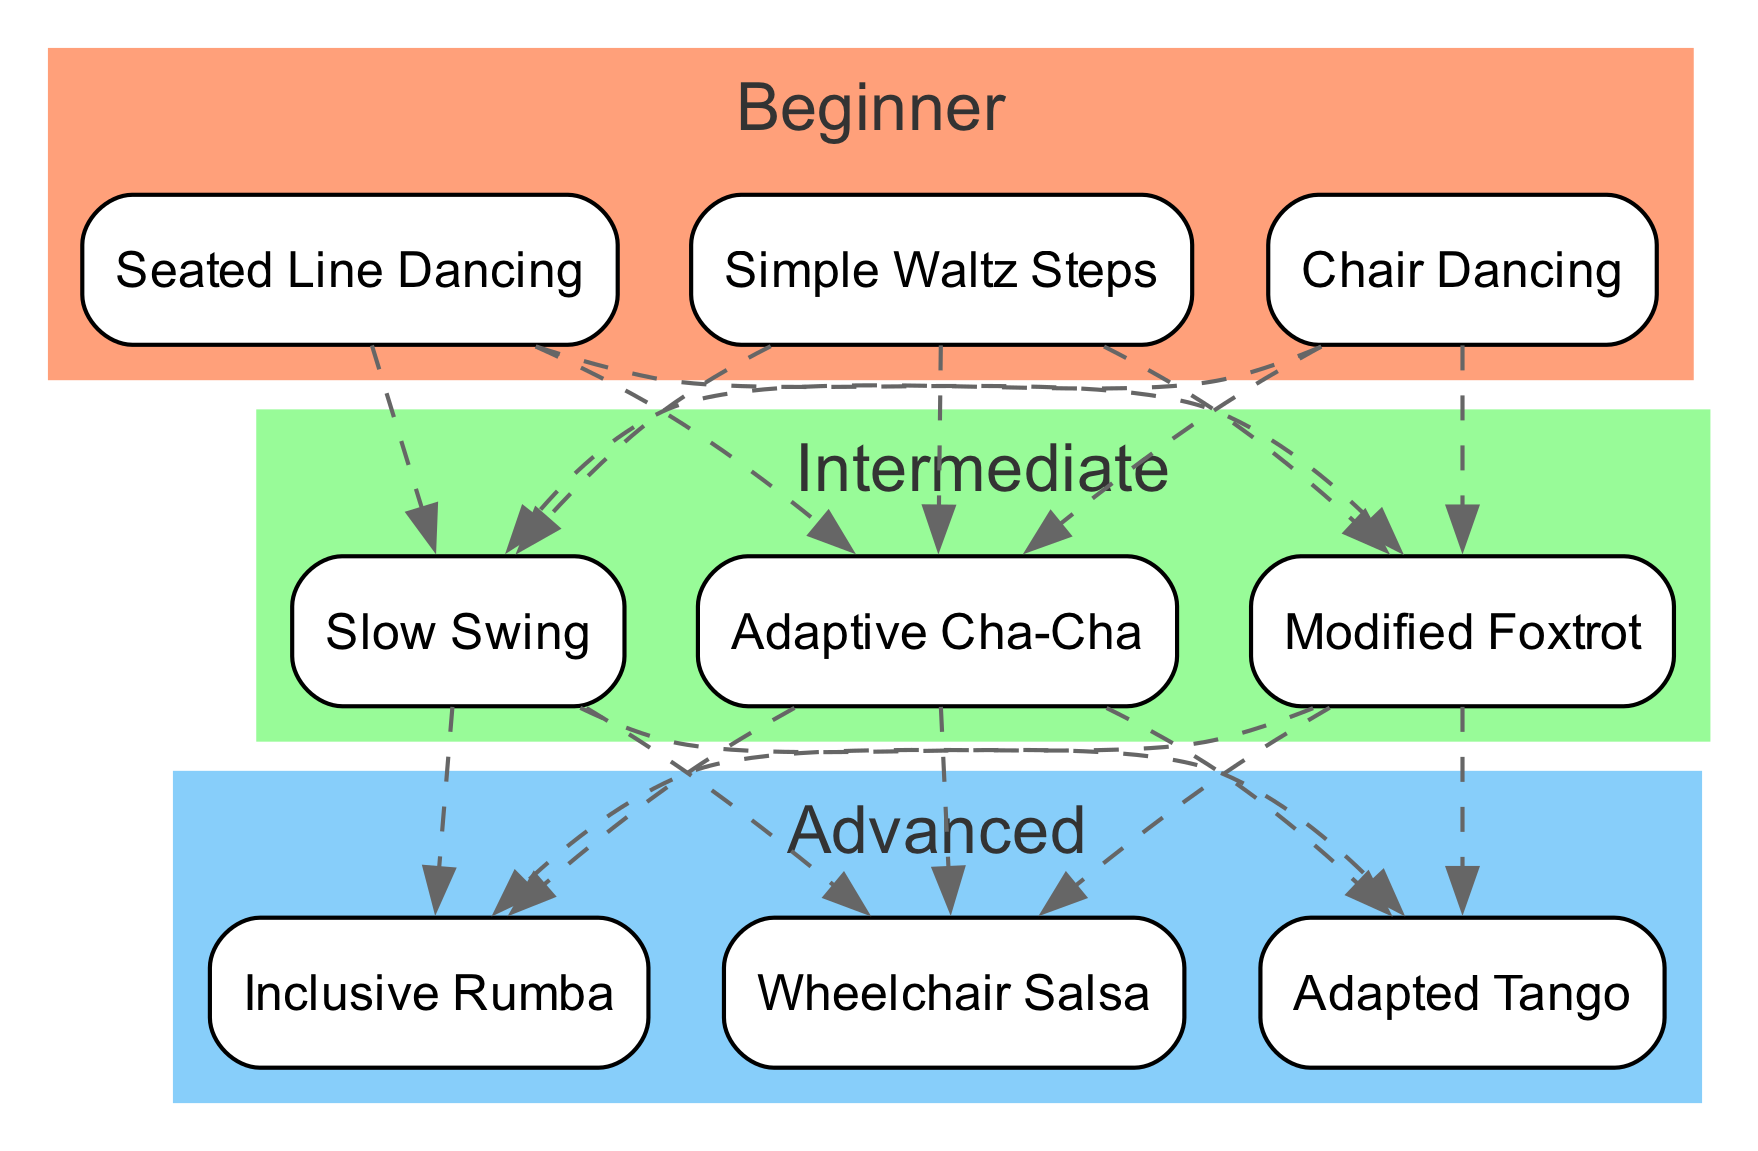What are the dance styles in the Beginner level? The Beginner level includes three styles: Chair Dancing, Seated Line Dancing, and Simple Waltz Steps. This can be directly observed by looking at the node labels under the "Beginner" cluster.
Answer: Chair Dancing, Seated Line Dancing, Simple Waltz Steps How many styles are listed under Intermediate? In the Intermediate level, there are three styles: Adaptive Cha-Cha, Modified Foxtrot, and Slow Swing. Counting the names listed gives us a total of three styles.
Answer: 3 What is the highest skill level shown in the diagram? The diagram presents three levels of skills: Beginner, Intermediate, and Advanced. The hierarchy indicates that Advanced is the top level of skill demonstrated in the diagram.
Answer: Advanced Which styles connect Beginner to Intermediate levels? The dashed edges in the diagram show connections between the styles in the Beginner and Intermediate levels. Specifically, each Beginner style connects to all Intermediate styles, but the specific styles are not named; rather, it's the connections that are significant.
Answer: All Beginner styles connect Name a style taught at the Advanced level. In the Advanced level, the three styles listed are Wheelchair Salsa, Adapted Tango, and Inclusive Rumba. Any of these can be named in response to the question.
Answer: Wheelchair Salsa What is the relationship between Seated Line Dancing and Adaptive Cha-Cha? Seated Line Dancing is a style in the Beginner level, while Adaptive Cha-Cha is from the Intermediate level. The dashed line indicates a connection from Beginner to Intermediate styles, signifying that these styles are part of a progression in skill.
Answer: Connected through progression How many nodes are there in the Advanced level? The Advanced level contains three distinct dance styles: Wheelchair Salsa, Adapted Tango, and Inclusive Rumba, which counts as three nodes.
Answer: 3 Which dance style acts as a bridge between Intermediate and Advanced levels? Each style in the Intermediate level connects to all styles in the Advanced level according to the dashed lines that indicate connections from the Intermediate to the Advanced styles. Thus, there is no single bridge style, but rather all Intermediate styles serve this purpose.
Answer: All Intermediate styles serve as bridges 